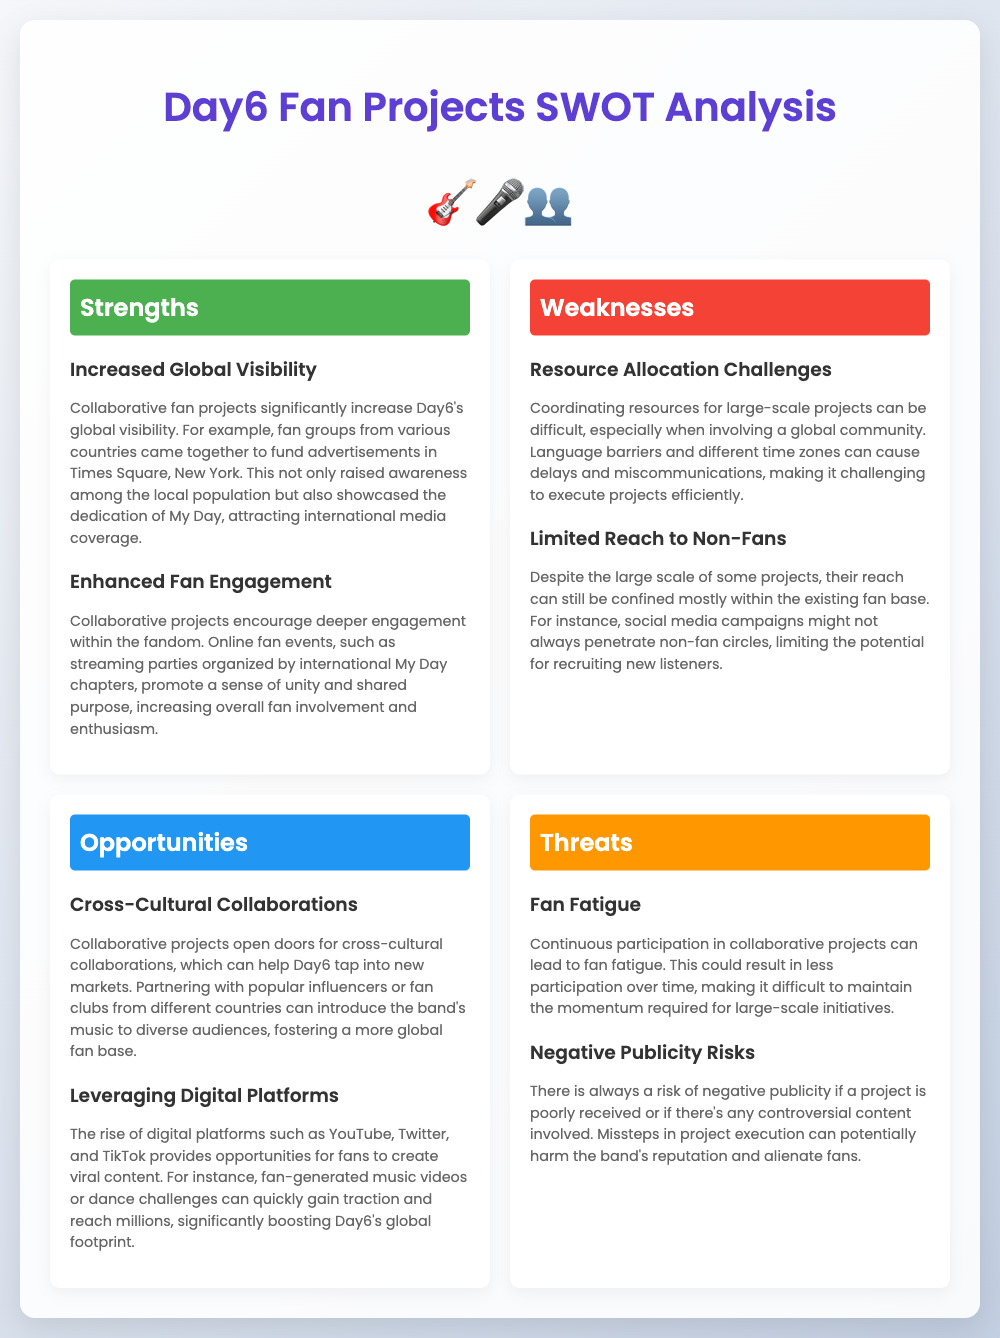What is one strength of collaborative fan projects? The section on strengths mentions that collaborative fan projects significantly increase Day6's global visibility.
Answer: Increased Global Visibility What challenge is highlighted in the weaknesses section? One of the weaknesses discussed is the difficulty in coordinating resources for large-scale projects.
Answer: Resource Allocation Challenges What opportunity can collaborative projects provide for Day6? The document states that collaborative projects open doors for cross-cultural collaborations, which can help Day6 tap into new markets.
Answer: Cross-Cultural Collaborations How can digital platforms benefit collaborative fan projects? Leveraging digital platforms can provide fans the opportunity to create viral content, boosting Day6's global footprint.
Answer: Leveraging Digital Platforms What is a potential threat mentioned in the analysis? One of the threats identified is the risk of negative publicity if a project is poorly received.
Answer: Negative Publicity Risks What specific fan project raised awareness in New York? The document illustrates that fan groups funded advertisements in Times Square, New York.
Answer: Advertisements in Times Square How do collaborative projects enhance fan involvement? The analysis states that online fan events promote a sense of unity and shared purpose among fans.
Answer: Enhanced Fan Engagement What type of content can fans create for promotion? The document mentions fan-generated music videos or dance challenges as examples of content fans can create.
Answer: Music videos or dance challenges 